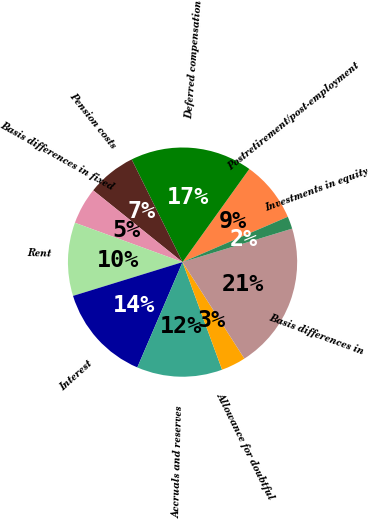<chart> <loc_0><loc_0><loc_500><loc_500><pie_chart><fcel>Postretirement/post-employment<fcel>Deferred compensation<fcel>Pension costs<fcel>Basis differences in fixed<fcel>Rent<fcel>Interest<fcel>Accruals and reserves<fcel>Allowance for doubtful<fcel>Basis differences in<fcel>Investments in equity<nl><fcel>8.63%<fcel>17.22%<fcel>6.91%<fcel>5.19%<fcel>10.34%<fcel>13.78%<fcel>12.06%<fcel>3.47%<fcel>20.65%<fcel>1.75%<nl></chart> 